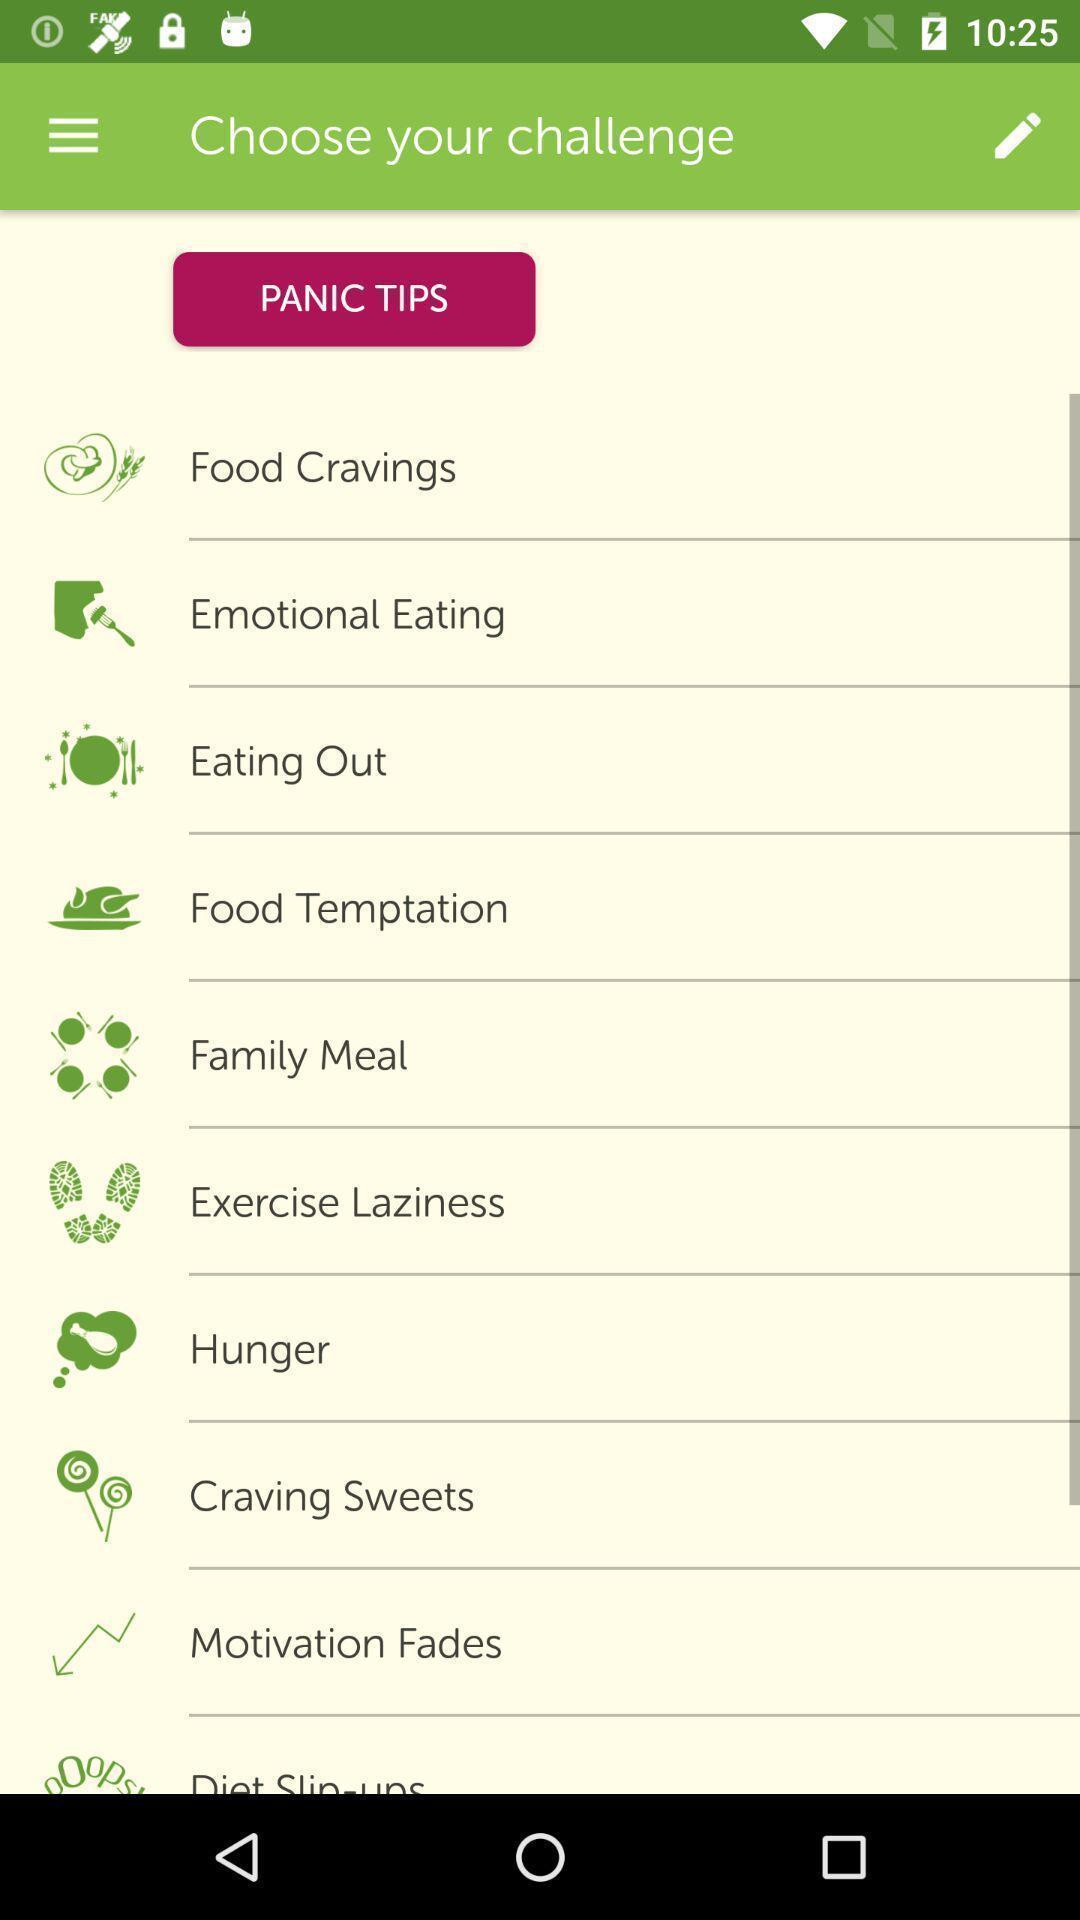What can you discern from this picture? Screen displaying multiple options in a health navigation application. 